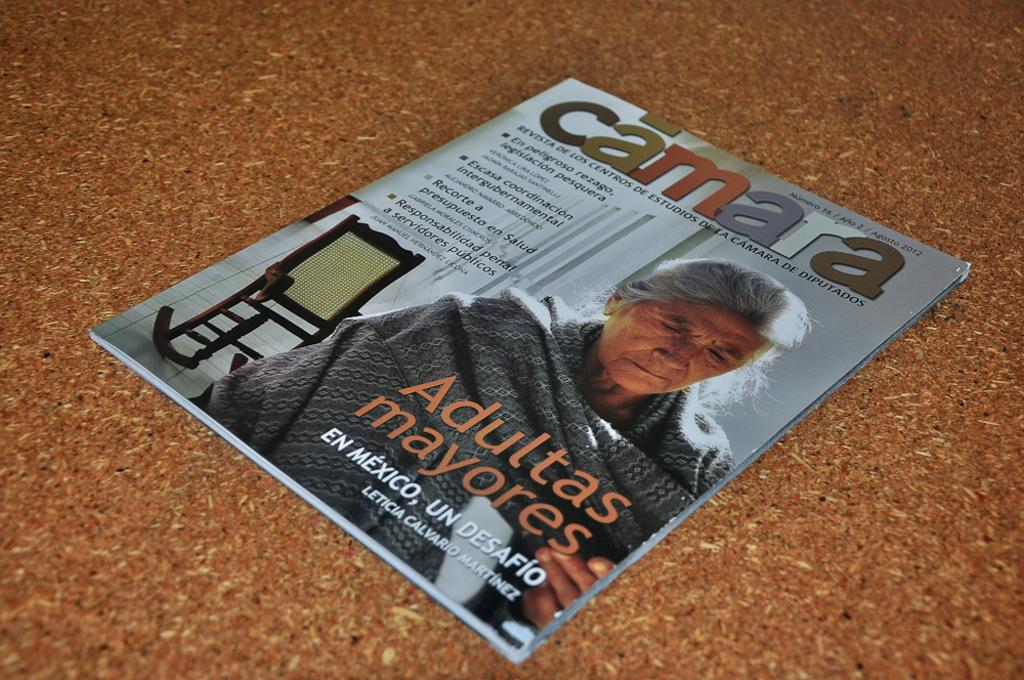Who is featured on the cover of the magazine in the image? There is an old woman on the cover of a magazine in the image. What is the surface on which the magazine is placed? The magazine is on a wooden table in the image. What type of zinc is visible on the old woman's hat in the image? There is no hat or zinc present in the image. How does the beginner feel about the old woman's appearance in the image? There is no information about a beginner's feelings or opinions in the image. 